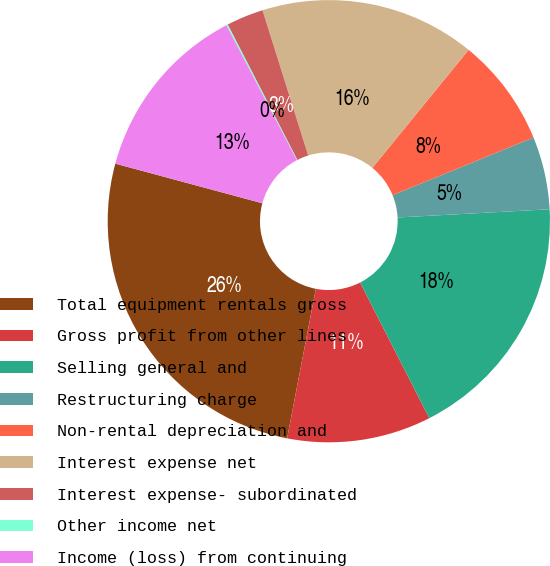<chart> <loc_0><loc_0><loc_500><loc_500><pie_chart><fcel>Total equipment rentals gross<fcel>Gross profit from other lines<fcel>Selling general and<fcel>Restructuring charge<fcel>Non-rental depreciation and<fcel>Interest expense net<fcel>Interest expense- subordinated<fcel>Other income net<fcel>Income (loss) from continuing<nl><fcel>26.17%<fcel>10.53%<fcel>18.35%<fcel>5.32%<fcel>7.93%<fcel>15.74%<fcel>2.71%<fcel>0.11%<fcel>13.14%<nl></chart> 